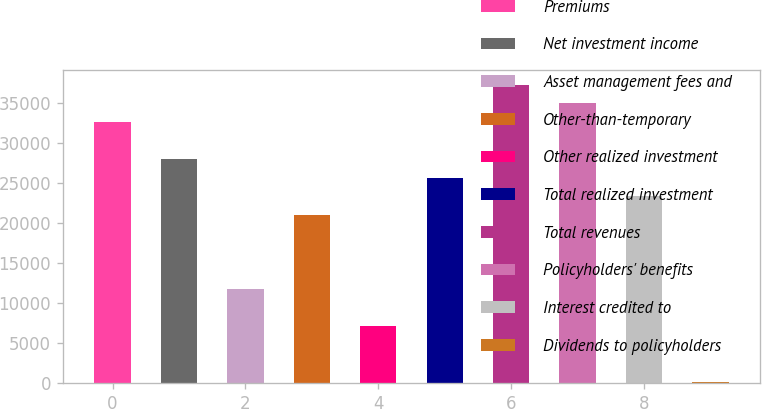Convert chart to OTSL. <chart><loc_0><loc_0><loc_500><loc_500><bar_chart><fcel>Premiums<fcel>Net investment income<fcel>Asset management fees and<fcel>Other-than-temporary<fcel>Other realized investment<fcel>Total realized investment<fcel>Total revenues<fcel>Policyholders' benefits<fcel>Interest credited to<fcel>Dividends to policyholders<nl><fcel>32602.6<fcel>27958.8<fcel>11705.5<fcel>20993.1<fcel>7061.7<fcel>25636.9<fcel>37246.4<fcel>34924.5<fcel>23315<fcel>96<nl></chart> 